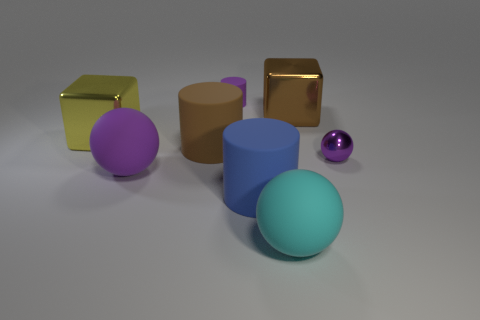Add 1 blue spheres. How many objects exist? 9 Subtract all cylinders. How many objects are left? 5 Add 8 small purple rubber objects. How many small purple rubber objects exist? 9 Subtract 0 cyan cylinders. How many objects are left? 8 Subtract all tiny cyan balls. Subtract all big cyan objects. How many objects are left? 7 Add 1 small purple shiny spheres. How many small purple shiny spheres are left? 2 